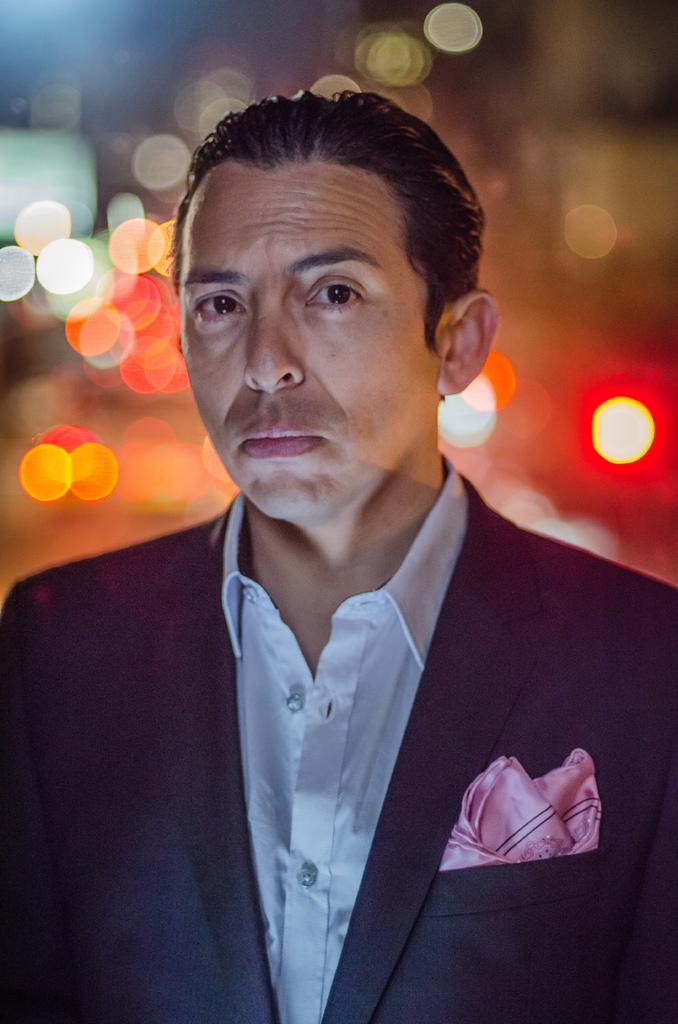What color is the shirt that the man in the image is wearing? The man in the image is wearing a white shirt. What type of outerwear is the man wearing? The man is wearing a black blazer. What is the man's facial expression or action in the image? The man is looking at the camera. What can be seen behind the man in the image? There are lights visible behind the man. How would you describe the background of the image? The background of the image is blurred. What type of cake is being served on the hose in the image? There is no cake or hose present in the image. What is the man doing with the iron in the image? There is no iron present in the image. 